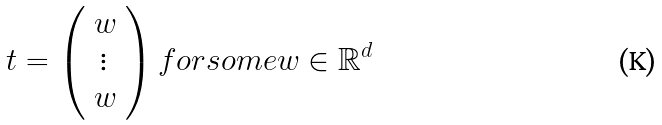Convert formula to latex. <formula><loc_0><loc_0><loc_500><loc_500>t = \left ( \begin{array} { c } w \\ \vdots \\ w \end{array} \right ) f o r s o m e w \in \mathbb { R } ^ { d }</formula> 